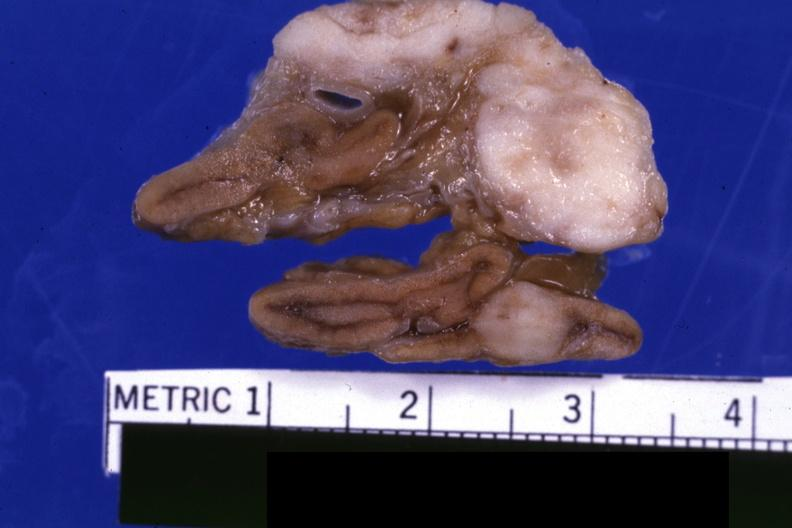does this image show fixed tissue close-up view shows tumor very well lung adenocarcinoma?
Answer the question using a single word or phrase. Yes 